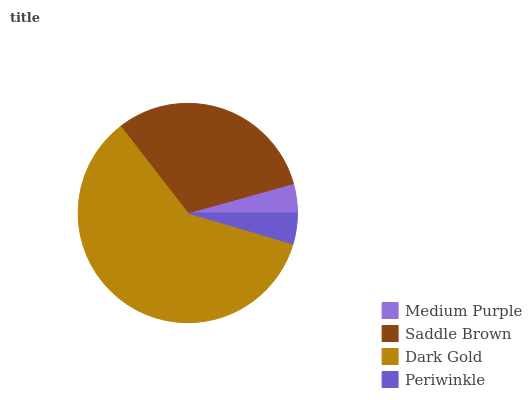Is Medium Purple the minimum?
Answer yes or no. Yes. Is Dark Gold the maximum?
Answer yes or no. Yes. Is Saddle Brown the minimum?
Answer yes or no. No. Is Saddle Brown the maximum?
Answer yes or no. No. Is Saddle Brown greater than Medium Purple?
Answer yes or no. Yes. Is Medium Purple less than Saddle Brown?
Answer yes or no. Yes. Is Medium Purple greater than Saddle Brown?
Answer yes or no. No. Is Saddle Brown less than Medium Purple?
Answer yes or no. No. Is Saddle Brown the high median?
Answer yes or no. Yes. Is Periwinkle the low median?
Answer yes or no. Yes. Is Dark Gold the high median?
Answer yes or no. No. Is Dark Gold the low median?
Answer yes or no. No. 